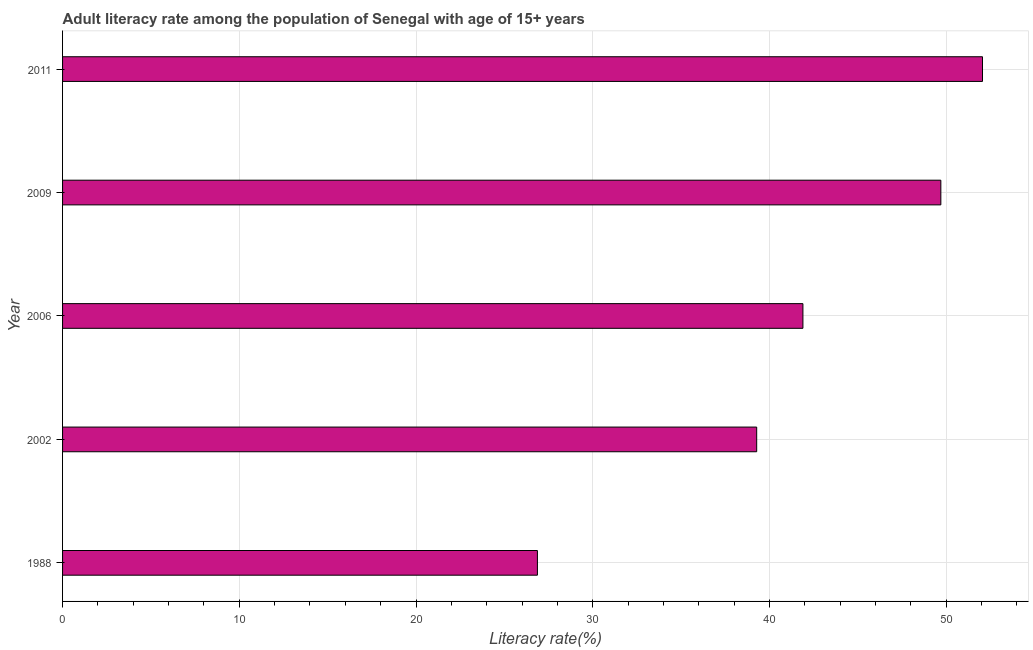Does the graph contain any zero values?
Give a very brief answer. No. What is the title of the graph?
Provide a succinct answer. Adult literacy rate among the population of Senegal with age of 15+ years. What is the label or title of the X-axis?
Make the answer very short. Literacy rate(%). What is the label or title of the Y-axis?
Make the answer very short. Year. What is the adult literacy rate in 2002?
Your response must be concise. 39.28. Across all years, what is the maximum adult literacy rate?
Give a very brief answer. 52.05. Across all years, what is the minimum adult literacy rate?
Make the answer very short. 26.87. In which year was the adult literacy rate maximum?
Give a very brief answer. 2011. In which year was the adult literacy rate minimum?
Offer a very short reply. 1988. What is the sum of the adult literacy rate?
Offer a very short reply. 209.78. What is the difference between the adult literacy rate in 1988 and 2002?
Provide a succinct answer. -12.41. What is the average adult literacy rate per year?
Your response must be concise. 41.96. What is the median adult literacy rate?
Ensure brevity in your answer.  41.89. Do a majority of the years between 2009 and 2011 (inclusive) have adult literacy rate greater than 36 %?
Offer a very short reply. Yes. What is the ratio of the adult literacy rate in 2006 to that in 2009?
Your response must be concise. 0.84. What is the difference between the highest and the second highest adult literacy rate?
Provide a short and direct response. 2.36. Is the sum of the adult literacy rate in 2006 and 2011 greater than the maximum adult literacy rate across all years?
Keep it short and to the point. Yes. What is the difference between the highest and the lowest adult literacy rate?
Provide a short and direct response. 25.18. In how many years, is the adult literacy rate greater than the average adult literacy rate taken over all years?
Make the answer very short. 2. Are the values on the major ticks of X-axis written in scientific E-notation?
Provide a succinct answer. No. What is the Literacy rate(%) in 1988?
Make the answer very short. 26.87. What is the Literacy rate(%) of 2002?
Ensure brevity in your answer.  39.28. What is the Literacy rate(%) of 2006?
Provide a short and direct response. 41.89. What is the Literacy rate(%) of 2009?
Offer a very short reply. 49.7. What is the Literacy rate(%) of 2011?
Offer a very short reply. 52.05. What is the difference between the Literacy rate(%) in 1988 and 2002?
Your answer should be compact. -12.41. What is the difference between the Literacy rate(%) in 1988 and 2006?
Ensure brevity in your answer.  -15.02. What is the difference between the Literacy rate(%) in 1988 and 2009?
Your response must be concise. -22.83. What is the difference between the Literacy rate(%) in 1988 and 2011?
Provide a short and direct response. -25.18. What is the difference between the Literacy rate(%) in 2002 and 2006?
Your answer should be compact. -2.62. What is the difference between the Literacy rate(%) in 2002 and 2009?
Your answer should be compact. -10.42. What is the difference between the Literacy rate(%) in 2002 and 2011?
Your answer should be very brief. -12.78. What is the difference between the Literacy rate(%) in 2006 and 2009?
Keep it short and to the point. -7.8. What is the difference between the Literacy rate(%) in 2006 and 2011?
Give a very brief answer. -10.16. What is the difference between the Literacy rate(%) in 2009 and 2011?
Provide a short and direct response. -2.36. What is the ratio of the Literacy rate(%) in 1988 to that in 2002?
Keep it short and to the point. 0.68. What is the ratio of the Literacy rate(%) in 1988 to that in 2006?
Offer a terse response. 0.64. What is the ratio of the Literacy rate(%) in 1988 to that in 2009?
Give a very brief answer. 0.54. What is the ratio of the Literacy rate(%) in 1988 to that in 2011?
Offer a terse response. 0.52. What is the ratio of the Literacy rate(%) in 2002 to that in 2006?
Give a very brief answer. 0.94. What is the ratio of the Literacy rate(%) in 2002 to that in 2009?
Offer a very short reply. 0.79. What is the ratio of the Literacy rate(%) in 2002 to that in 2011?
Make the answer very short. 0.76. What is the ratio of the Literacy rate(%) in 2006 to that in 2009?
Your answer should be very brief. 0.84. What is the ratio of the Literacy rate(%) in 2006 to that in 2011?
Keep it short and to the point. 0.81. What is the ratio of the Literacy rate(%) in 2009 to that in 2011?
Keep it short and to the point. 0.95. 